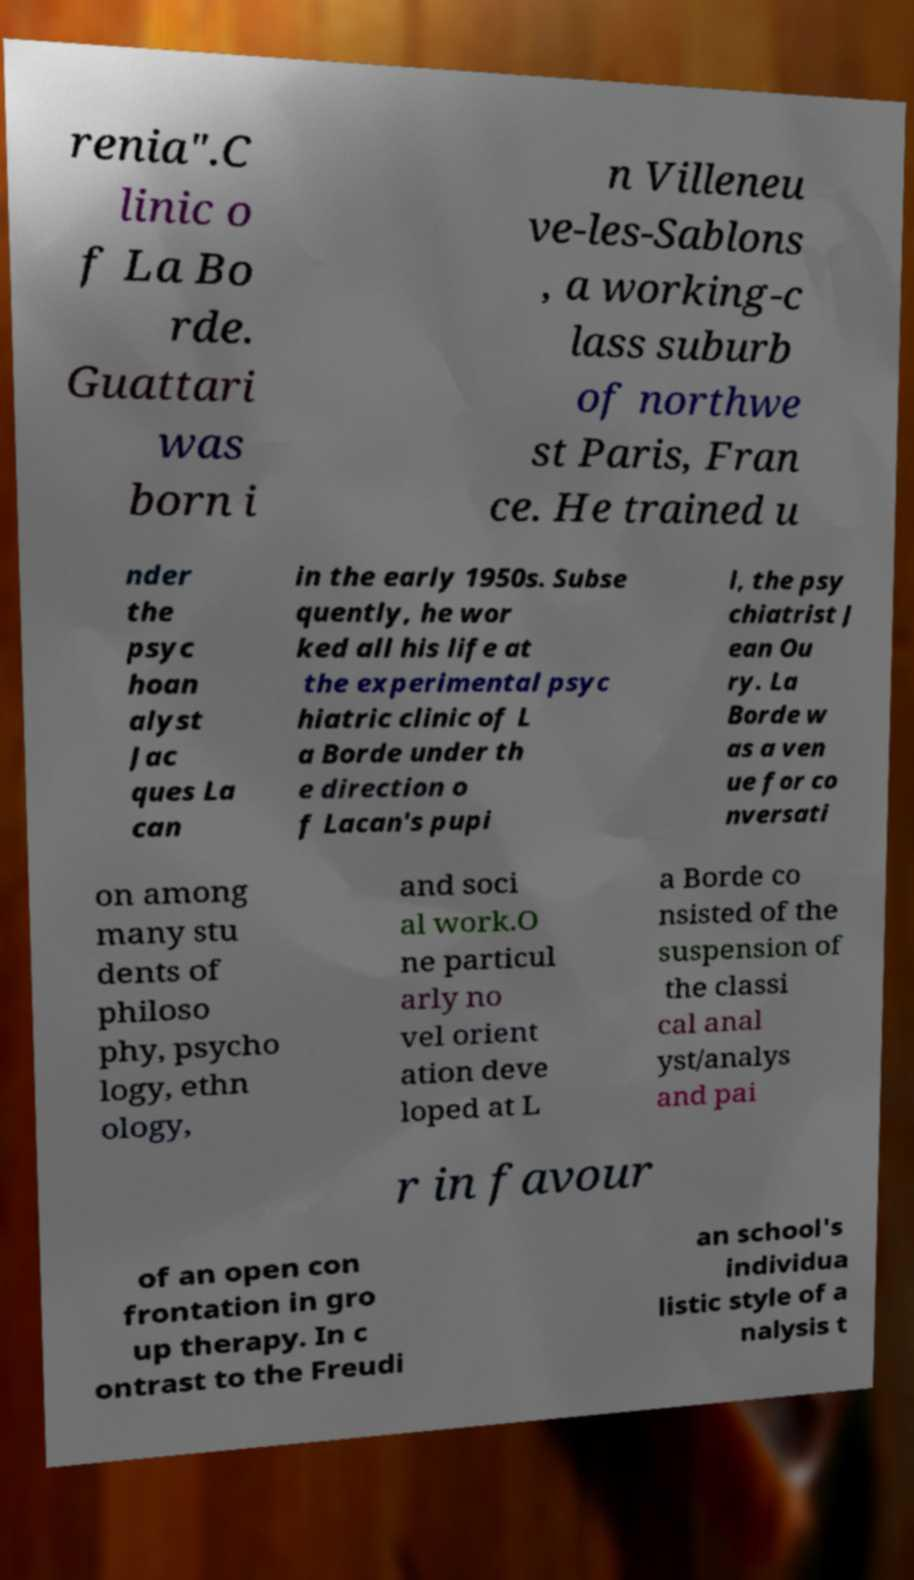I need the written content from this picture converted into text. Can you do that? renia".C linic o f La Bo rde. Guattari was born i n Villeneu ve-les-Sablons , a working-c lass suburb of northwe st Paris, Fran ce. He trained u nder the psyc hoan alyst Jac ques La can in the early 1950s. Subse quently, he wor ked all his life at the experimental psyc hiatric clinic of L a Borde under th e direction o f Lacan's pupi l, the psy chiatrist J ean Ou ry. La Borde w as a ven ue for co nversati on among many stu dents of philoso phy, psycho logy, ethn ology, and soci al work.O ne particul arly no vel orient ation deve loped at L a Borde co nsisted of the suspension of the classi cal anal yst/analys and pai r in favour of an open con frontation in gro up therapy. In c ontrast to the Freudi an school's individua listic style of a nalysis t 